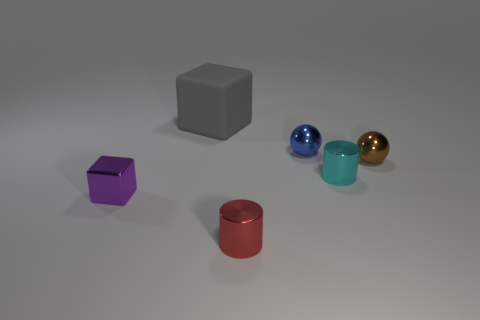Add 3 tiny blue balls. How many objects exist? 9 Subtract all cylinders. How many objects are left? 4 Subtract 1 cylinders. How many cylinders are left? 1 Subtract all brown balls. How many yellow blocks are left? 0 Subtract all purple metallic cubes. Subtract all blue spheres. How many objects are left? 4 Add 4 balls. How many balls are left? 6 Add 4 blue metal things. How many blue metal things exist? 5 Subtract 0 gray balls. How many objects are left? 6 Subtract all green spheres. Subtract all red cylinders. How many spheres are left? 2 